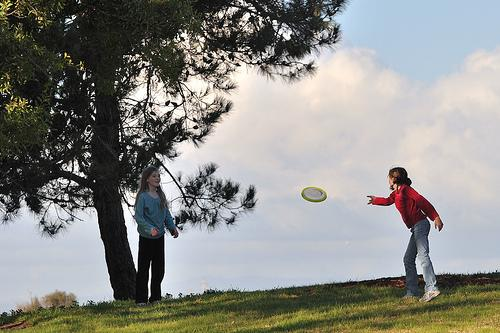Mention the clothing worn by the girls and the main activity they are engaged in. Two girls, one in a blue shirt and the other in a red shirt, are actively participating in a frisbee game. Provide a brief description of the primary action taking place in the image. Two girls, one wearing a blue shirt and the other in a red shirt, are playing frisbee outside, with the frisbee being thrown through the air between them. What are the two people doing in the image? In the image, two girls are playing frisbee with one girl throwing and the other getting ready to catch the frisbee. Using a casual tone, describe what you see in the picture. There are two girls hanging out in some park, it looks like they're just having a good time tossing a frisbee around. Describe the physical attributes of the girls and the nature around them, along with the main activity. In an outdoor setting with green grass, towering trees, and a vivid blue sky, two girls with long hair, one wearing a blue shirt and the other a red shirt, are playing frisbee. Describe the atmosphere and main activity occurring in the image. In a bright and lively outdoor setting with green grass and tall trees, two active girls are enthusiastically playing a game of frisbee. In a single sentence, depict the setting and the ongoing activity in the image. Under a sunny sky with puffy clouds, two energetic girls are enjoying a fun session of frisbee amidst a grassy landscape dotted with trees. Narrate the scene and mention the key color elements present in the image. In a picturesque setting featuring blue skies, white clouds, and verdant landscapes, two youthful girls in bright blue and red clothing engage in a jovial game of frisbee. Using a poetic style, describe the scene in the image. Beneath the blue sky with white clouds passing by, two lively lasses in colorful attire compete in a spirited game of airborne disc, surrounded by lush green meadows and towering trees. What sport activity is being played in the image and who is playing it? Frisbee is being played in the image by two girls, one wearing a blue shirt and the other wearing a red shirt. 